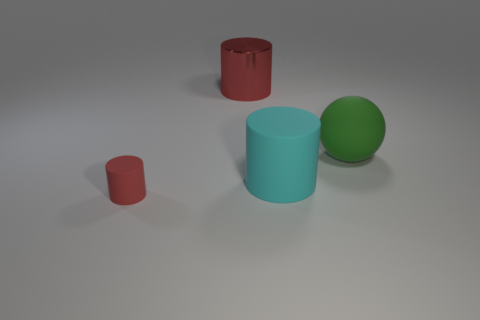Is the number of objects that are behind the large red metal object greater than the number of tiny brown shiny blocks?
Your answer should be very brief. No. What size is the cyan object that is the same shape as the red metallic thing?
Your answer should be compact. Large. Are there any other things that are made of the same material as the small object?
Keep it short and to the point. Yes. The tiny object is what shape?
Offer a terse response. Cylinder. What shape is the green matte thing that is the same size as the cyan object?
Keep it short and to the point. Sphere. Is there any other thing of the same color as the big ball?
Keep it short and to the point. No. There is a cyan cylinder that is made of the same material as the green sphere; what is its size?
Offer a terse response. Large. Does the large cyan rubber object have the same shape as the matte thing on the left side of the red metal cylinder?
Ensure brevity in your answer.  Yes. The cyan thing has what size?
Provide a succinct answer. Large. Are there fewer big red shiny cylinders that are left of the large ball than large rubber objects?
Your answer should be compact. Yes. 